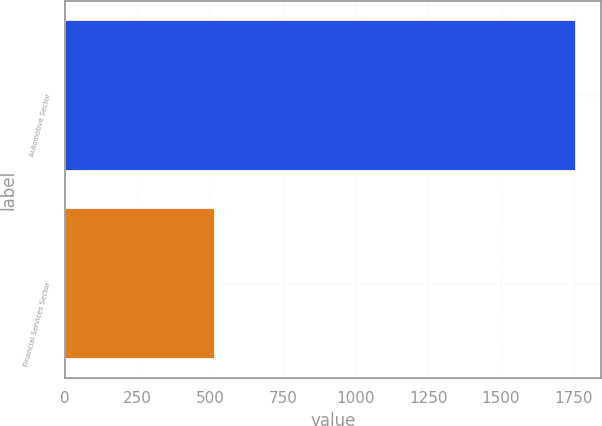Convert chart. <chart><loc_0><loc_0><loc_500><loc_500><bar_chart><fcel>Automotive Sector<fcel>Financial Services Sector<nl><fcel>1758<fcel>516<nl></chart> 